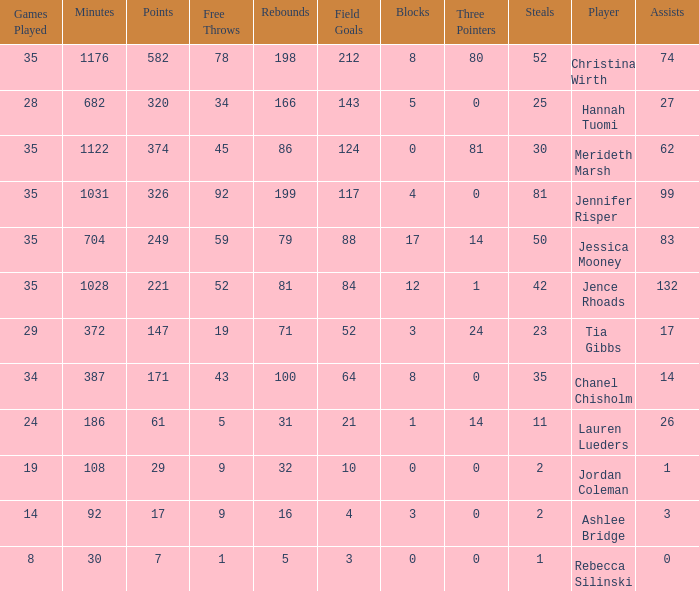What is the lowest number of 3 pointers that occured in games with 52 steals? 80.0. 